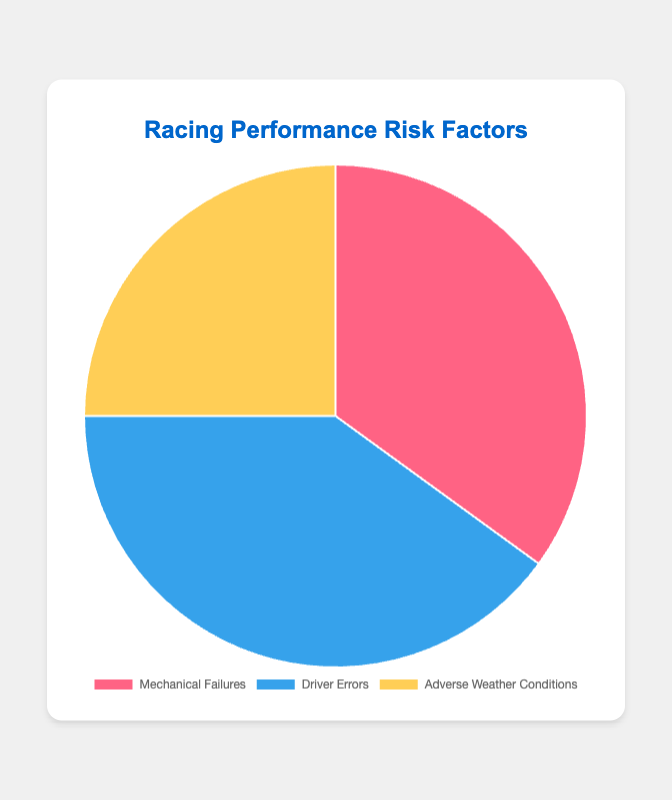What is the largest risk factor affecting performance? Based on the pie chart, the largest section is labeled "Driver Errors" with a proportion of 40%.
Answer: Driver Errors What proportion of risk factors are due to mechanical failures? Referring to the pie chart, the section labeled "Mechanical Failures" accounts for 35%.
Answer: 35% Which risk factor has the smallest proportion? Looking at the pie chart, "Adverse Weather Conditions" has the smallest section with 25%.
Answer: Adverse Weather Conditions What is the difference in proportion between Driver Errors and Adverse Weather Conditions? From the pie chart, Driver Errors are 40% and Adverse Weather Conditions are 25%. The difference is 40% - 25% = 15%.
Answer: 15% Combine the proportions of Mechanical Failures and Adverse Weather Conditions. What do you get? Adding the proportions from the chart: Mechanical Failures (35%) + Adverse Weather Conditions (25%) = 35% + 25% = 60%.
Answer: 60% Compare the proportions of Mechanical Failures and Driver Errors. Which one is higher and by how much? Driver Errors (40%) is higher than Mechanical Failures (35%). The difference is 40% - 35% = 5%.
Answer: Driver Errors by 5% What is the average proportion of the three risk factors? Summing the proportions from the pie chart: 35% + 40% + 25% = 100%. The average is 100% / 3 = approximately 33.33%.
Answer: 33.33% If you were to combine Mechanical Failures and Driver Errors, what percentage of the total would that make up? Adding the proportions from the pie chart: Mechanical Failures (35%) + Driver Errors (40%) = 35% + 40% = 75%.
Answer: 75% What is the color representing the Mechanical Failures section in the chart? The color coding in the pie chart shows "Mechanical Failures" as represented in red.
Answer: Red 